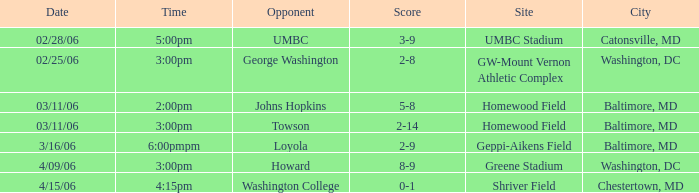What is the Date if the Site is Shriver Field? 4/15/06. 